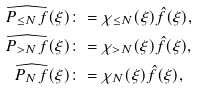Convert formula to latex. <formula><loc_0><loc_0><loc_500><loc_500>\widehat { P _ { \leq N } f } ( \xi ) & \colon = \chi _ { \leq N } ( \xi ) \hat { f } ( \xi ) , \\ \widehat { P _ { > N } f } ( \xi ) & \colon = \chi _ { > N } ( \xi ) \hat { f } ( \xi ) , \\ \widehat { P _ { N } f } ( \xi ) & \colon = \chi _ { N } ( \xi ) \hat { f } ( \xi ) ,</formula> 